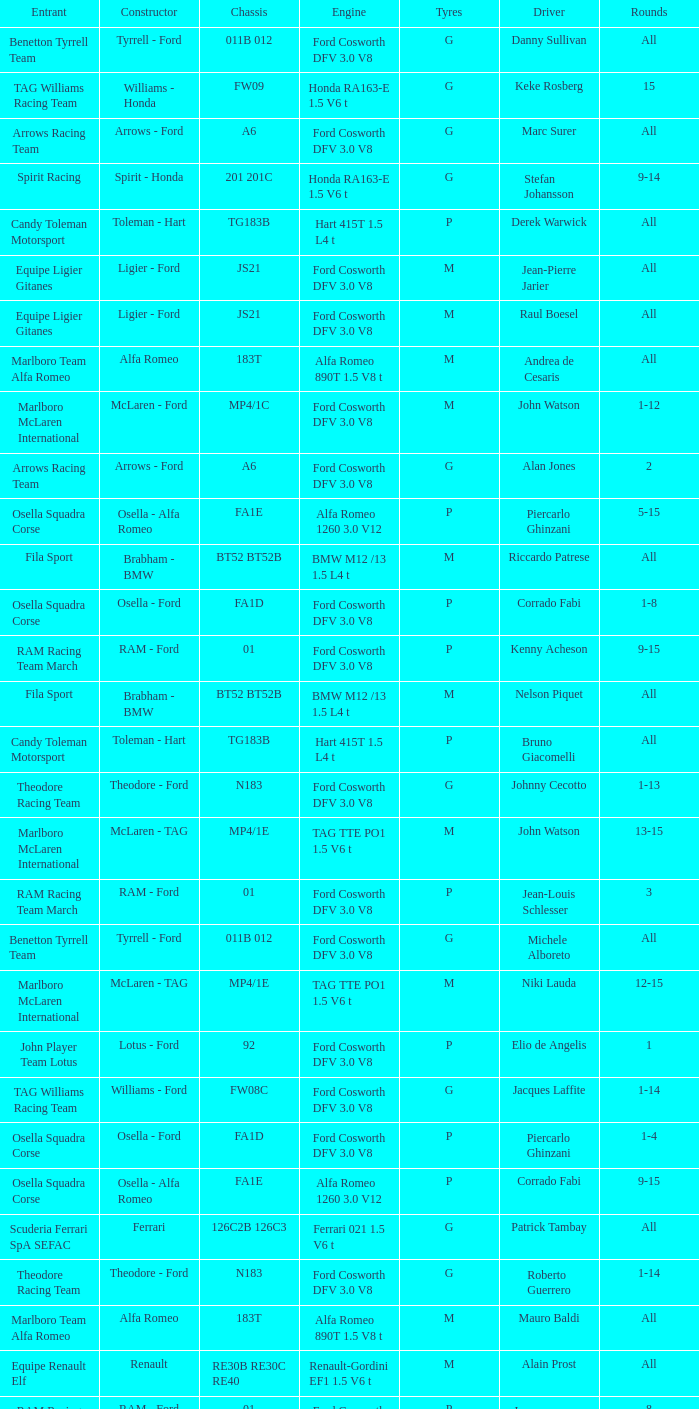Who is the constructor for driver Niki Lauda and a chassis of mp4/1c? McLaren - Ford. 